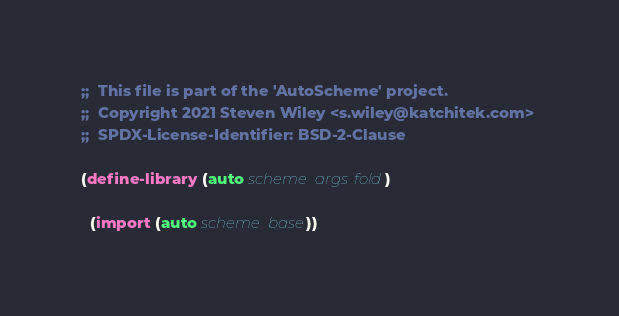<code> <loc_0><loc_0><loc_500><loc_500><_Scheme_>;;  This file is part of the 'AutoScheme' project.
;;  Copyright 2021 Steven Wiley <s.wiley@katchitek.com> 
;;  SPDX-License-Identifier: BSD-2-Clause

(define-library (auto scheme args fold)
  
  (import (auto scheme base))
</code> 